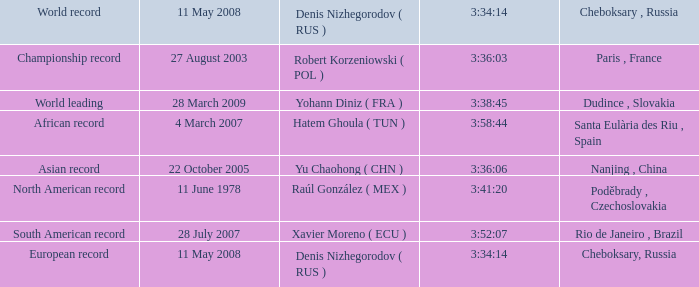When 3:41:20 is  3:34:14 what is cheboksary , russia? Poděbrady , Czechoslovakia. 